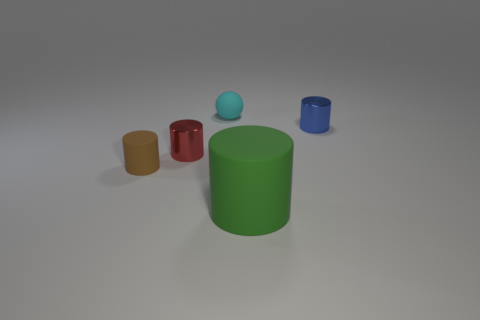What is the texture of the objects like? The objects exhibit a variety of textures: the green and red cylinders have smooth, matte finishes, the yellow and brown cylinders are smooth yet reflective, hinting at a shiny texture, and the blue sphere and blue cylinder seem to have a glossy finish with clear reflections. 